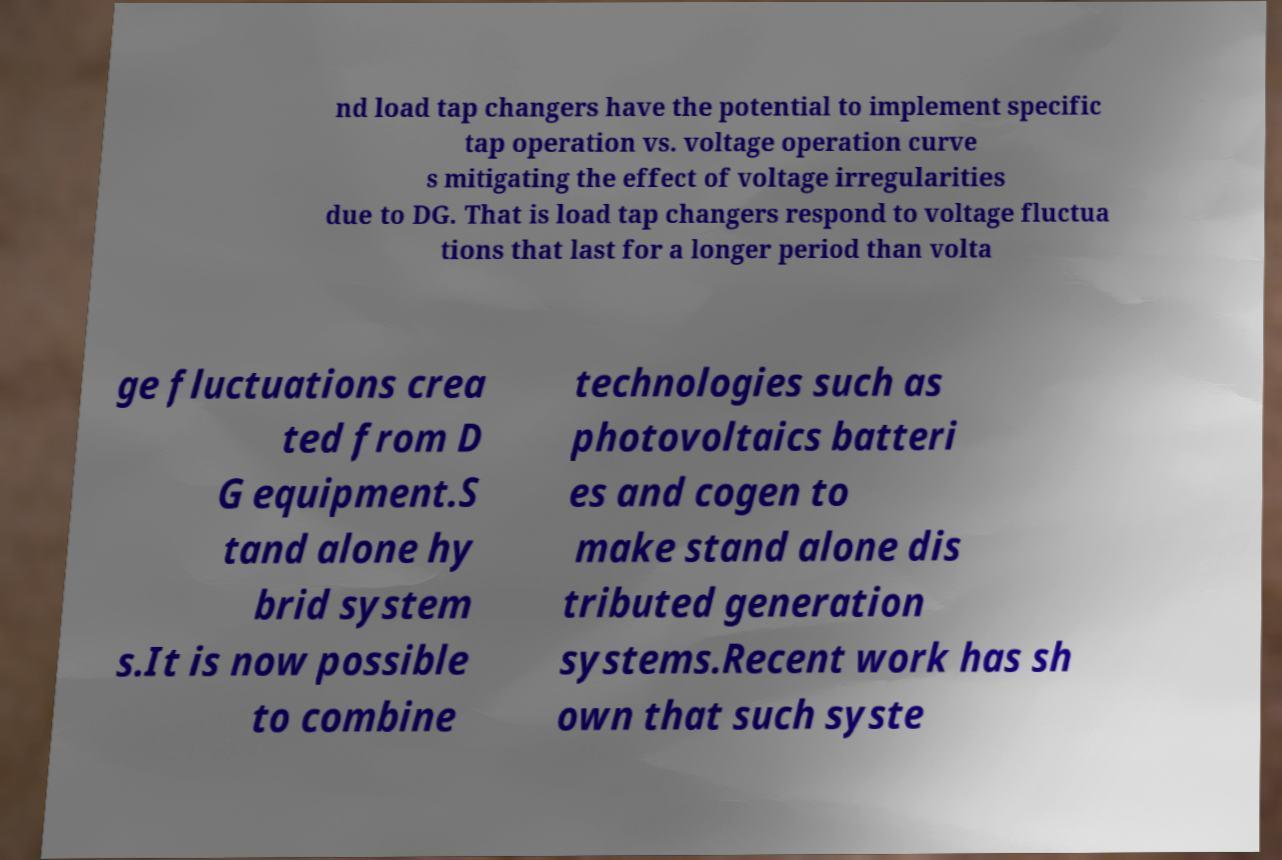There's text embedded in this image that I need extracted. Can you transcribe it verbatim? nd load tap changers have the potential to implement specific tap operation vs. voltage operation curve s mitigating the effect of voltage irregularities due to DG. That is load tap changers respond to voltage fluctua tions that last for a longer period than volta ge fluctuations crea ted from D G equipment.S tand alone hy brid system s.It is now possible to combine technologies such as photovoltaics batteri es and cogen to make stand alone dis tributed generation systems.Recent work has sh own that such syste 